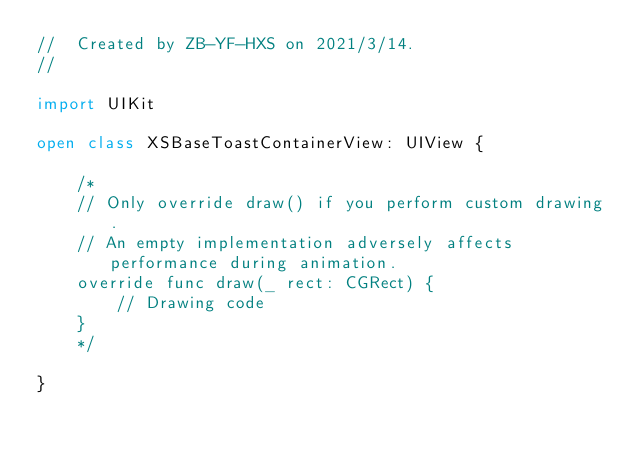Convert code to text. <code><loc_0><loc_0><loc_500><loc_500><_Swift_>//  Created by ZB-YF-HXS on 2021/3/14.
//

import UIKit

open class XSBaseToastContainerView: UIView {

    /*
    // Only override draw() if you perform custom drawing.
    // An empty implementation adversely affects performance during animation.
    override func draw(_ rect: CGRect) {
        // Drawing code
    }
    */

}
</code> 